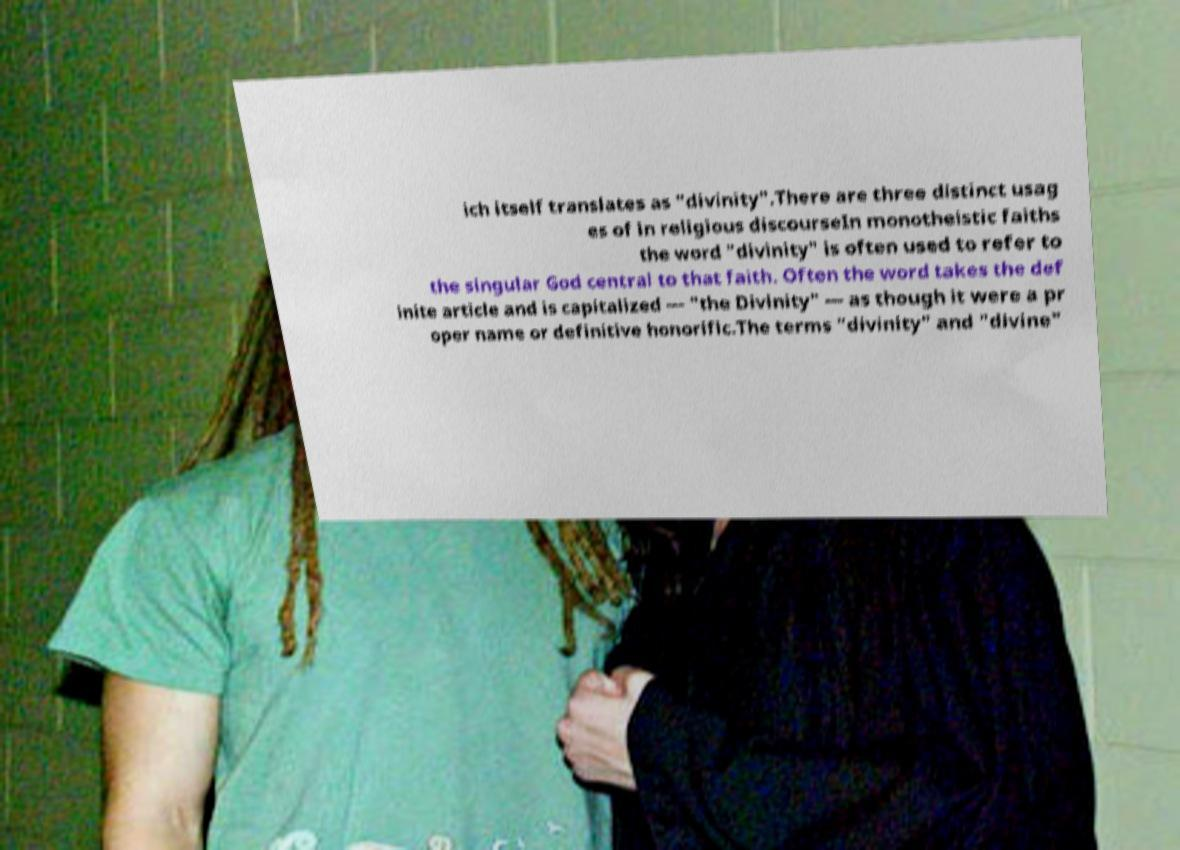Can you read and provide the text displayed in the image?This photo seems to have some interesting text. Can you extract and type it out for me? ich itself translates as "divinity".There are three distinct usag es of in religious discourseIn monotheistic faiths the word "divinity" is often used to refer to the singular God central to that faith. Often the word takes the def inite article and is capitalized — "the Divinity" — as though it were a pr oper name or definitive honorific.The terms "divinity" and "divine" 